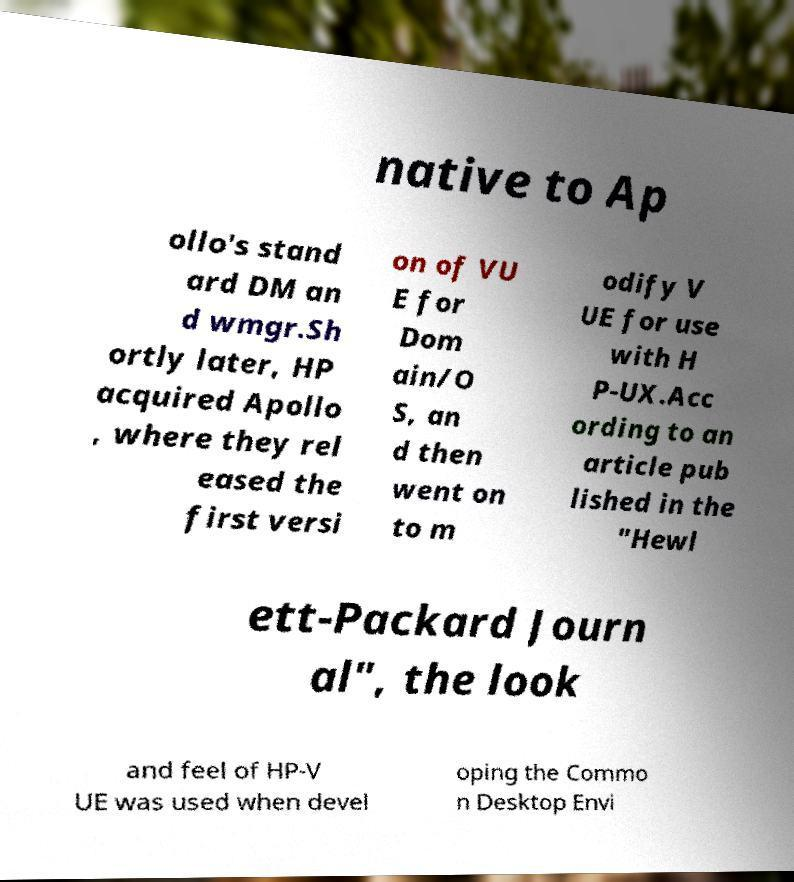Can you read and provide the text displayed in the image?This photo seems to have some interesting text. Can you extract and type it out for me? native to Ap ollo's stand ard DM an d wmgr.Sh ortly later, HP acquired Apollo , where they rel eased the first versi on of VU E for Dom ain/O S, an d then went on to m odify V UE for use with H P-UX.Acc ording to an article pub lished in the "Hewl ett-Packard Journ al", the look and feel of HP-V UE was used when devel oping the Commo n Desktop Envi 